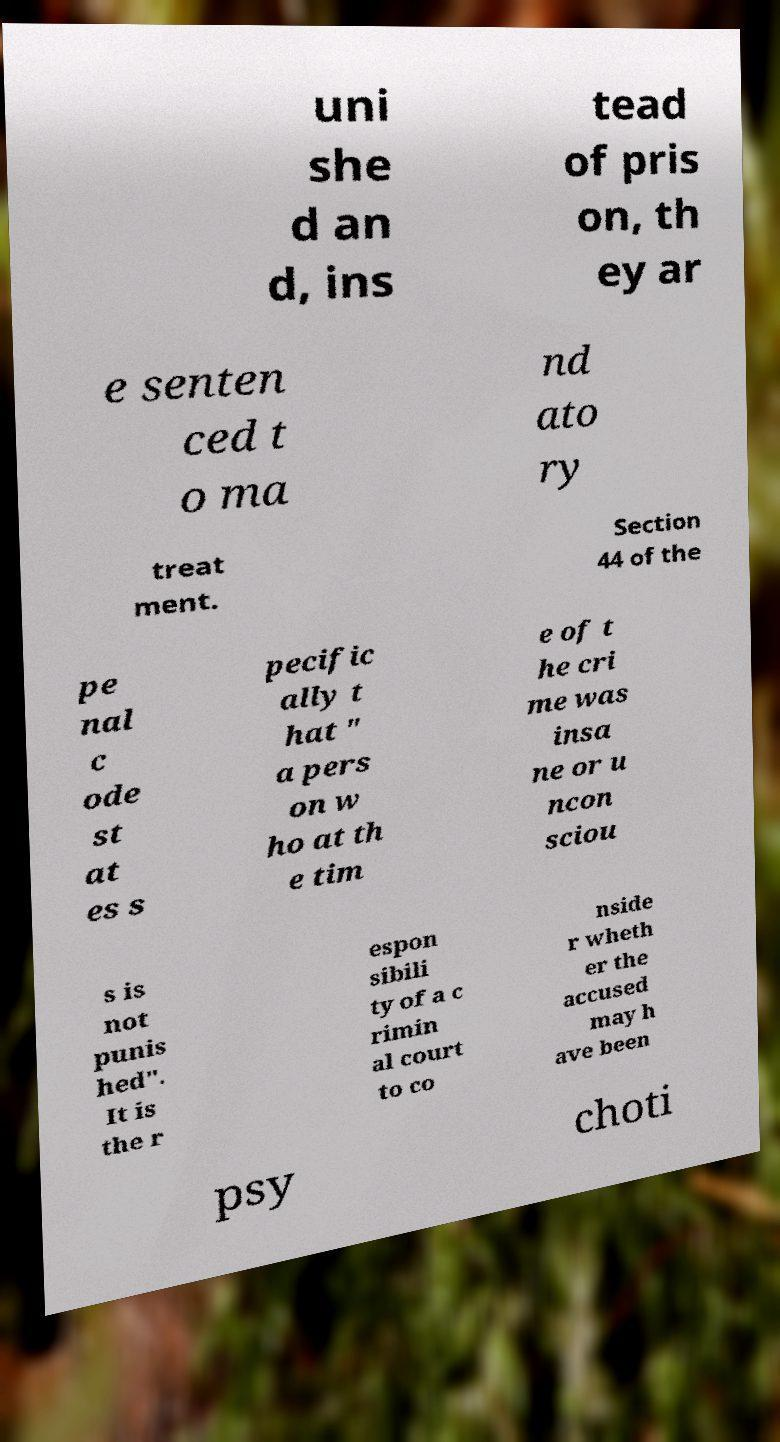Please read and relay the text visible in this image. What does it say? uni she d an d, ins tead of pris on, th ey ar e senten ced t o ma nd ato ry treat ment. Section 44 of the pe nal c ode st at es s pecific ally t hat " a pers on w ho at th e tim e of t he cri me was insa ne or u ncon sciou s is not punis hed". It is the r espon sibili ty of a c rimin al court to co nside r wheth er the accused may h ave been psy choti 